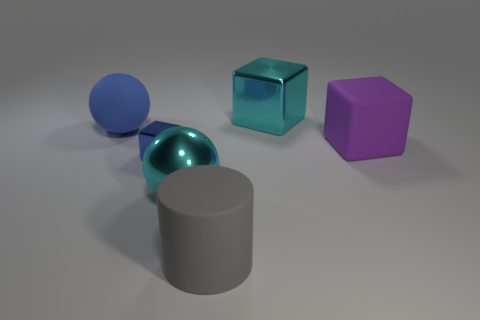Add 1 yellow matte cubes. How many objects exist? 7 Subtract all spheres. How many objects are left? 4 Add 6 tiny blocks. How many tiny blocks are left? 7 Add 5 large purple rubber blocks. How many large purple rubber blocks exist? 6 Subtract 0 purple cylinders. How many objects are left? 6 Subtract all large gray matte things. Subtract all tiny shiny objects. How many objects are left? 4 